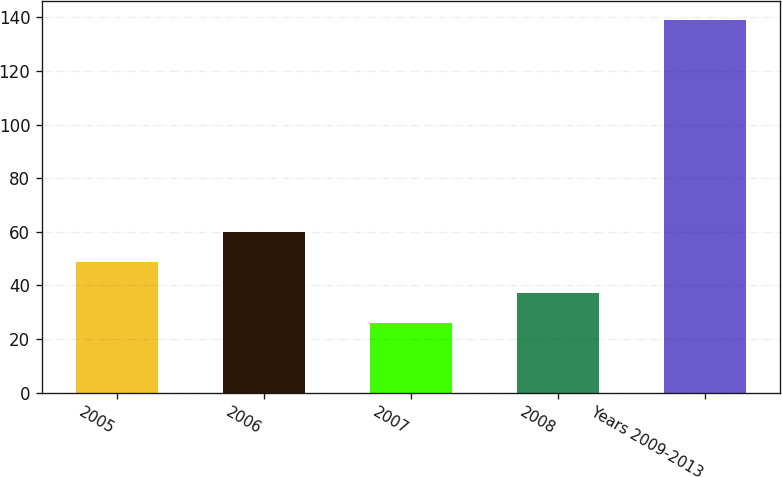Convert chart to OTSL. <chart><loc_0><loc_0><loc_500><loc_500><bar_chart><fcel>2005<fcel>2006<fcel>2007<fcel>2008<fcel>Years 2009-2013<nl><fcel>48.6<fcel>59.9<fcel>26<fcel>37.3<fcel>139<nl></chart> 